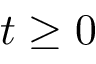<formula> <loc_0><loc_0><loc_500><loc_500>t \geq 0</formula> 